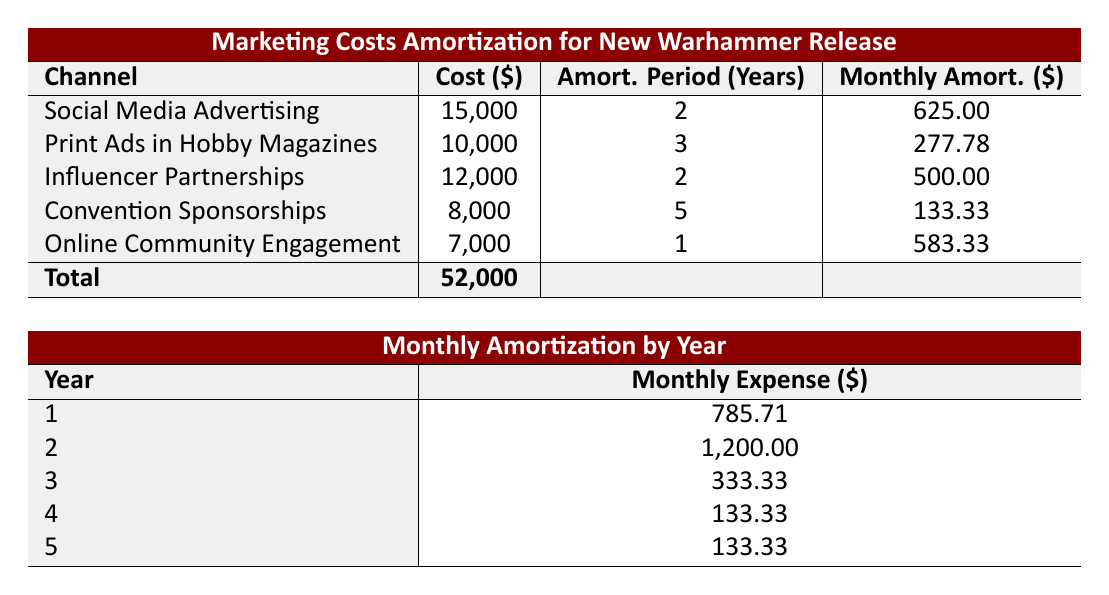What is the cost associated with Social Media Advertising? The table lists "Social Media Advertising" under the Channel column and shows the corresponding Cost in the same row which is $15,000.
Answer: 15,000 What is the total marketing cost in the amortization table? By checking the Total row at the bottom of the Cost column, we see that the total marketing cost is $52,000.
Answer: 52,000 How much is the monthly amortization for Online Community Engagement? The table shows the Monthly Amortization for Online Community Engagement listed as $583.33 under the corresponding channel.
Answer: 583.33 Is the amortization period for Print Ads in Hobby Magazines longer than 2 years? In the table, we find that the amortization period for Print Ads in Hobby Magazines is 3 years, which is indeed longer than 2 years.
Answer: Yes If we sum the monthly amortizations for years 1 and 2, what is the total? The monthly amortization for year 1 is $785.71 and for year 2 is $1,200. Therefore, adding these two values gives $785.71 + $1,200 = $1,985.71.
Answer: 1,985.71 What is the average monthly amortization across all years? To find this, we first need to sum all the monthly expenses from the years 1 through 5. The total is $785.71 + $1,200 + $333.33 + $133.33 + $133.33 = $2,585.70. Then, we divide by the number of years (5 years), so $2,585.70 / 5 = $517.14.
Answer: 517.14 Does the Convention Sponsorships incur a higher monthly amortization than Influencer Partnerships? The monthly amortization for Convention Sponsorships is $133.33 while for Influencer Partnerships, it is $500.00. Since $133.33 is less than $500.00, the statement is false.
Answer: No In which year is the monthly expense the lowest? Reviewing the monthly expenses by year, we see for years 4 and 5 the amount is $133.33, which is the lowest compared to the other years. Therefore, both year 4 and year 5 have the same lowest amount.
Answer: Year 4 and Year 5 